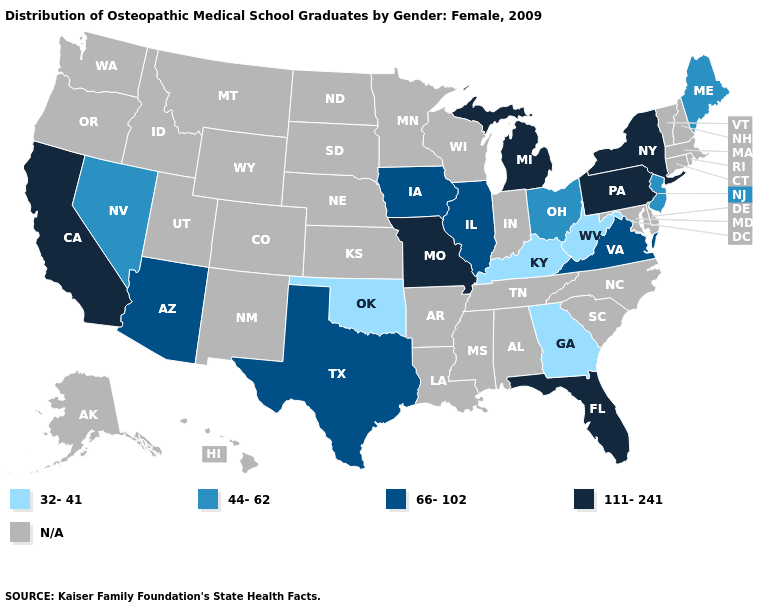Name the states that have a value in the range 66-102?
Short answer required. Arizona, Illinois, Iowa, Texas, Virginia. Name the states that have a value in the range 111-241?
Concise answer only. California, Florida, Michigan, Missouri, New York, Pennsylvania. Does Nevada have the highest value in the West?
Be succinct. No. Which states have the lowest value in the USA?
Keep it brief. Georgia, Kentucky, Oklahoma, West Virginia. Name the states that have a value in the range 44-62?
Give a very brief answer. Maine, Nevada, New Jersey, Ohio. Does Georgia have the highest value in the South?
Answer briefly. No. Does the map have missing data?
Quick response, please. Yes. What is the value of Indiana?
Short answer required. N/A. What is the lowest value in the USA?
Quick response, please. 32-41. Name the states that have a value in the range 111-241?
Short answer required. California, Florida, Michigan, Missouri, New York, Pennsylvania. Name the states that have a value in the range 111-241?
Keep it brief. California, Florida, Michigan, Missouri, New York, Pennsylvania. Which states have the highest value in the USA?
Concise answer only. California, Florida, Michigan, Missouri, New York, Pennsylvania. Which states have the lowest value in the South?
Be succinct. Georgia, Kentucky, Oklahoma, West Virginia. Name the states that have a value in the range 111-241?
Give a very brief answer. California, Florida, Michigan, Missouri, New York, Pennsylvania. 